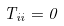Convert formula to latex. <formula><loc_0><loc_0><loc_500><loc_500>T _ { i i } = 0</formula> 